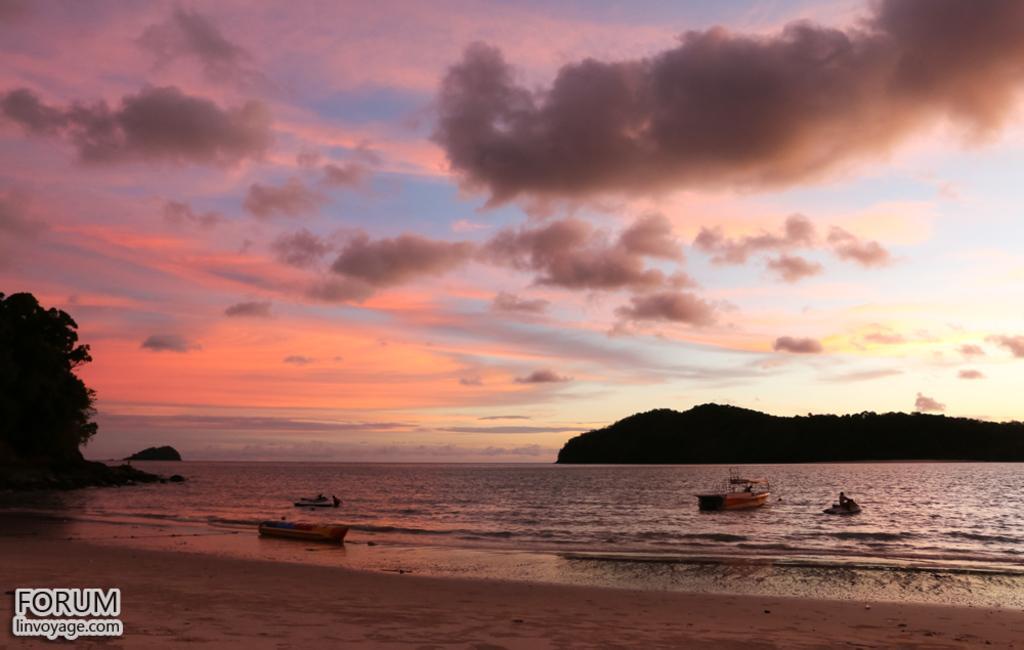Can you describe this image briefly? This is an outside view. At the bottom of the image there is a beach. There are few boats on the water. On the right side there is a hill. On the left side, I can see few trees. At the top of the image I can see the sky and clouds. 